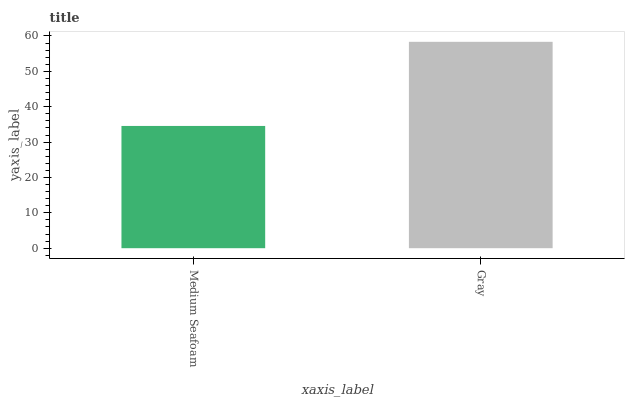Is Medium Seafoam the minimum?
Answer yes or no. Yes. Is Gray the maximum?
Answer yes or no. Yes. Is Gray the minimum?
Answer yes or no. No. Is Gray greater than Medium Seafoam?
Answer yes or no. Yes. Is Medium Seafoam less than Gray?
Answer yes or no. Yes. Is Medium Seafoam greater than Gray?
Answer yes or no. No. Is Gray less than Medium Seafoam?
Answer yes or no. No. Is Gray the high median?
Answer yes or no. Yes. Is Medium Seafoam the low median?
Answer yes or no. Yes. Is Medium Seafoam the high median?
Answer yes or no. No. Is Gray the low median?
Answer yes or no. No. 